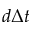Convert formula to latex. <formula><loc_0><loc_0><loc_500><loc_500>d \Delta t</formula> 